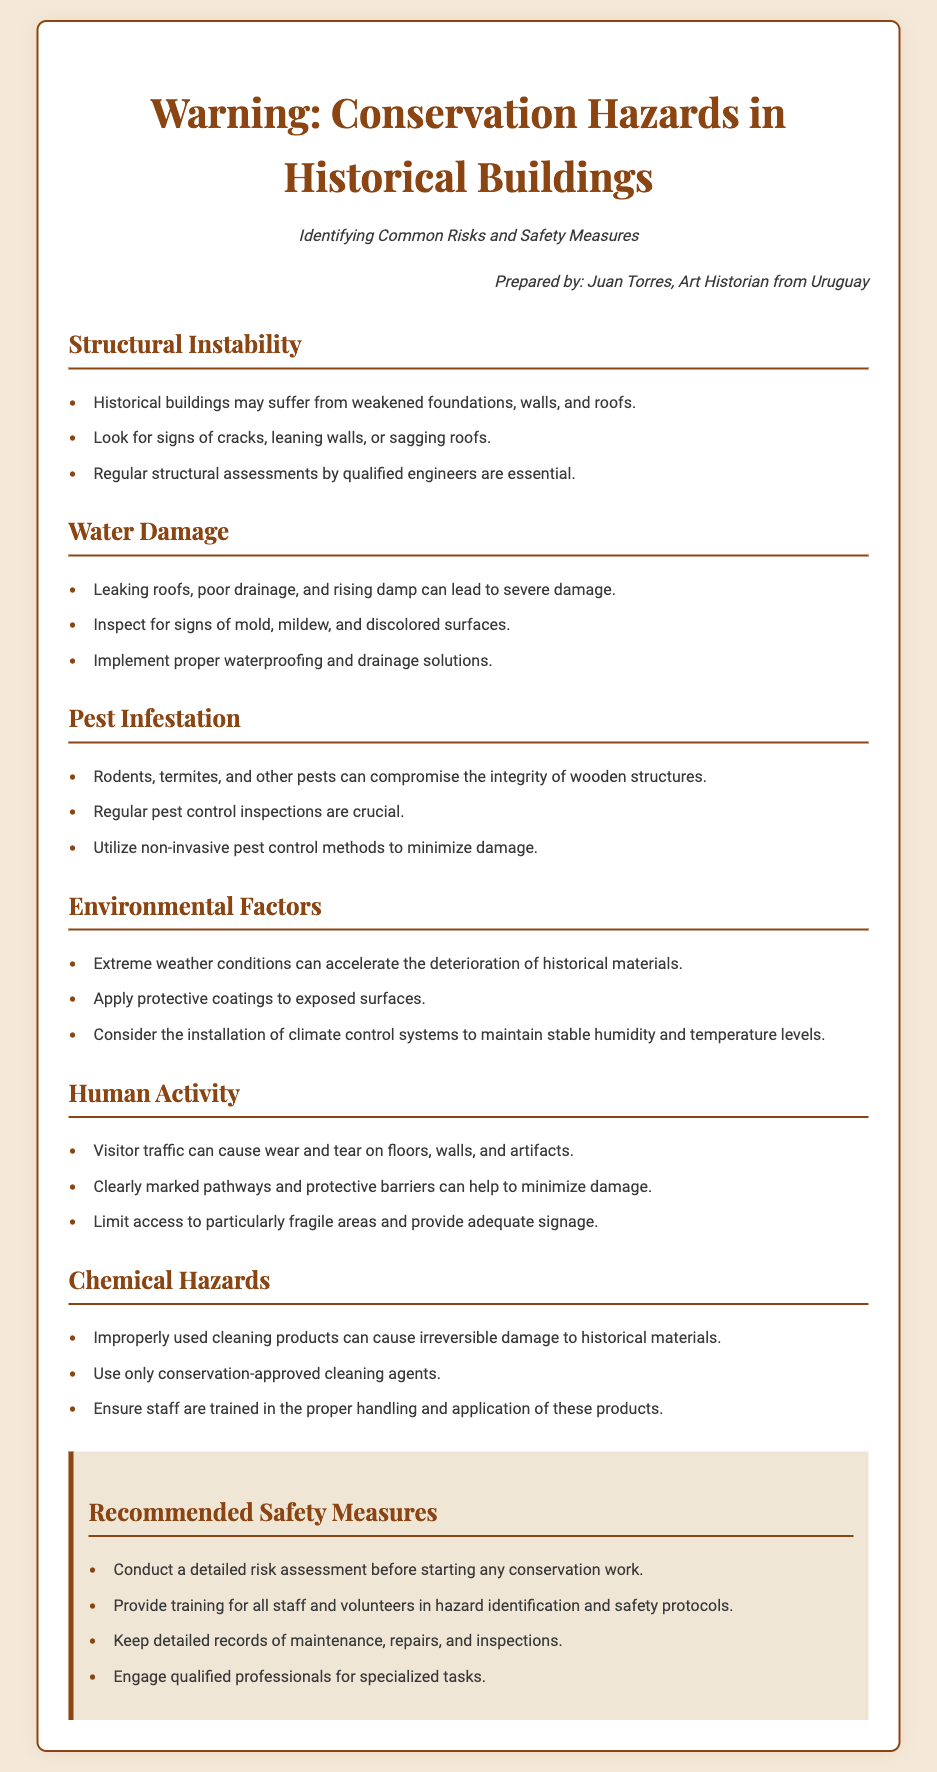What is the title of the document? The title is prominently displayed at the top of the document, indicating the main subject.
Answer: Warning: Conservation Hazards in Historical Buildings Who prepared the document? The author's name is included in the persona section, identifying the creator of the content.
Answer: Juan Torres What type of structural issues should be looked for? The document lists specific indicators of structural instability under the relevant section.
Answer: Cracks, leaning walls, or sagging roofs What is a common environmental factor affecting historical buildings? The document mentions specific environmental conditions that jeopardize historical materials.
Answer: Extreme weather conditions What should be used to inspect for pest infestations? The importance of inspections is highlighted specifically within the pest infestation section.
Answer: Regular pest control inspections What is one recommended safety measure? This is a clear directive given in the safety measures section, indicating best practices for conservation.
Answer: Conduct a detailed risk assessment before starting any conservation work What can cause irreversible damage to historical materials? The document warns about the dangers of a specific type of product in its chemical hazards section.
Answer: Improperly used cleaning products How can visitor traffic impact historical buildings? The implications of human activity on historical structures are addressed in a specific section.
Answer: Cause wear and tear on floors, walls, and artifacts 